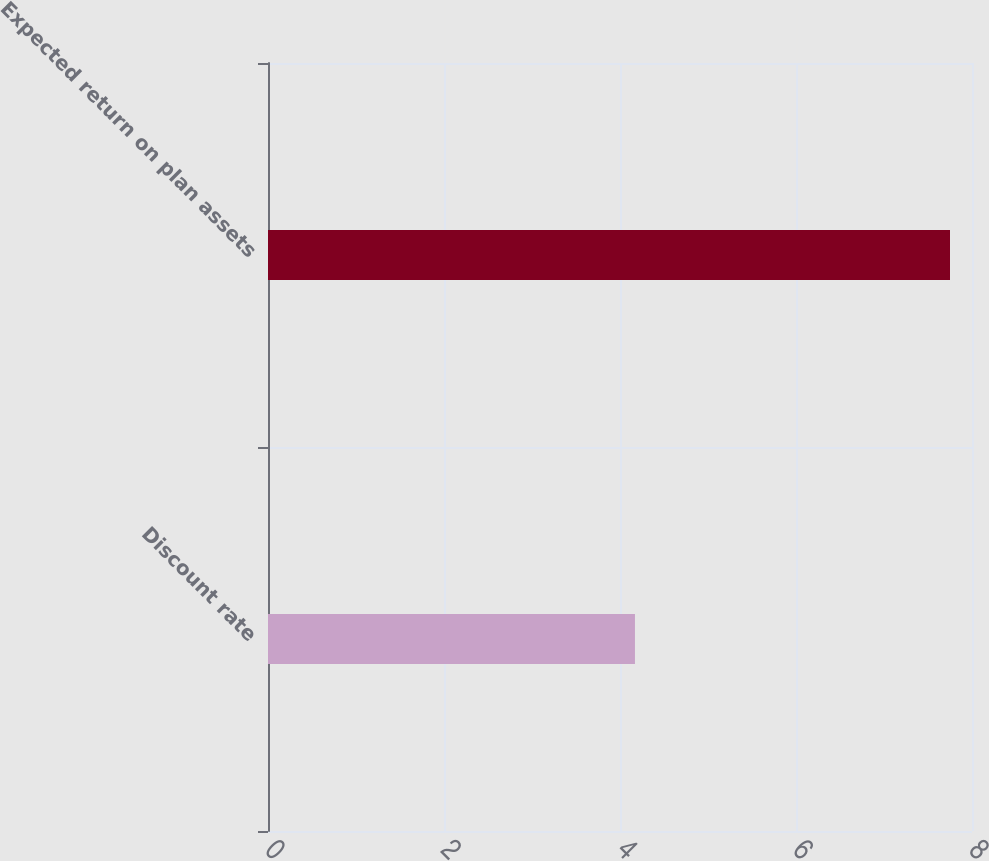<chart> <loc_0><loc_0><loc_500><loc_500><bar_chart><fcel>Discount rate<fcel>Expected return on plan assets<nl><fcel>4.17<fcel>7.75<nl></chart> 